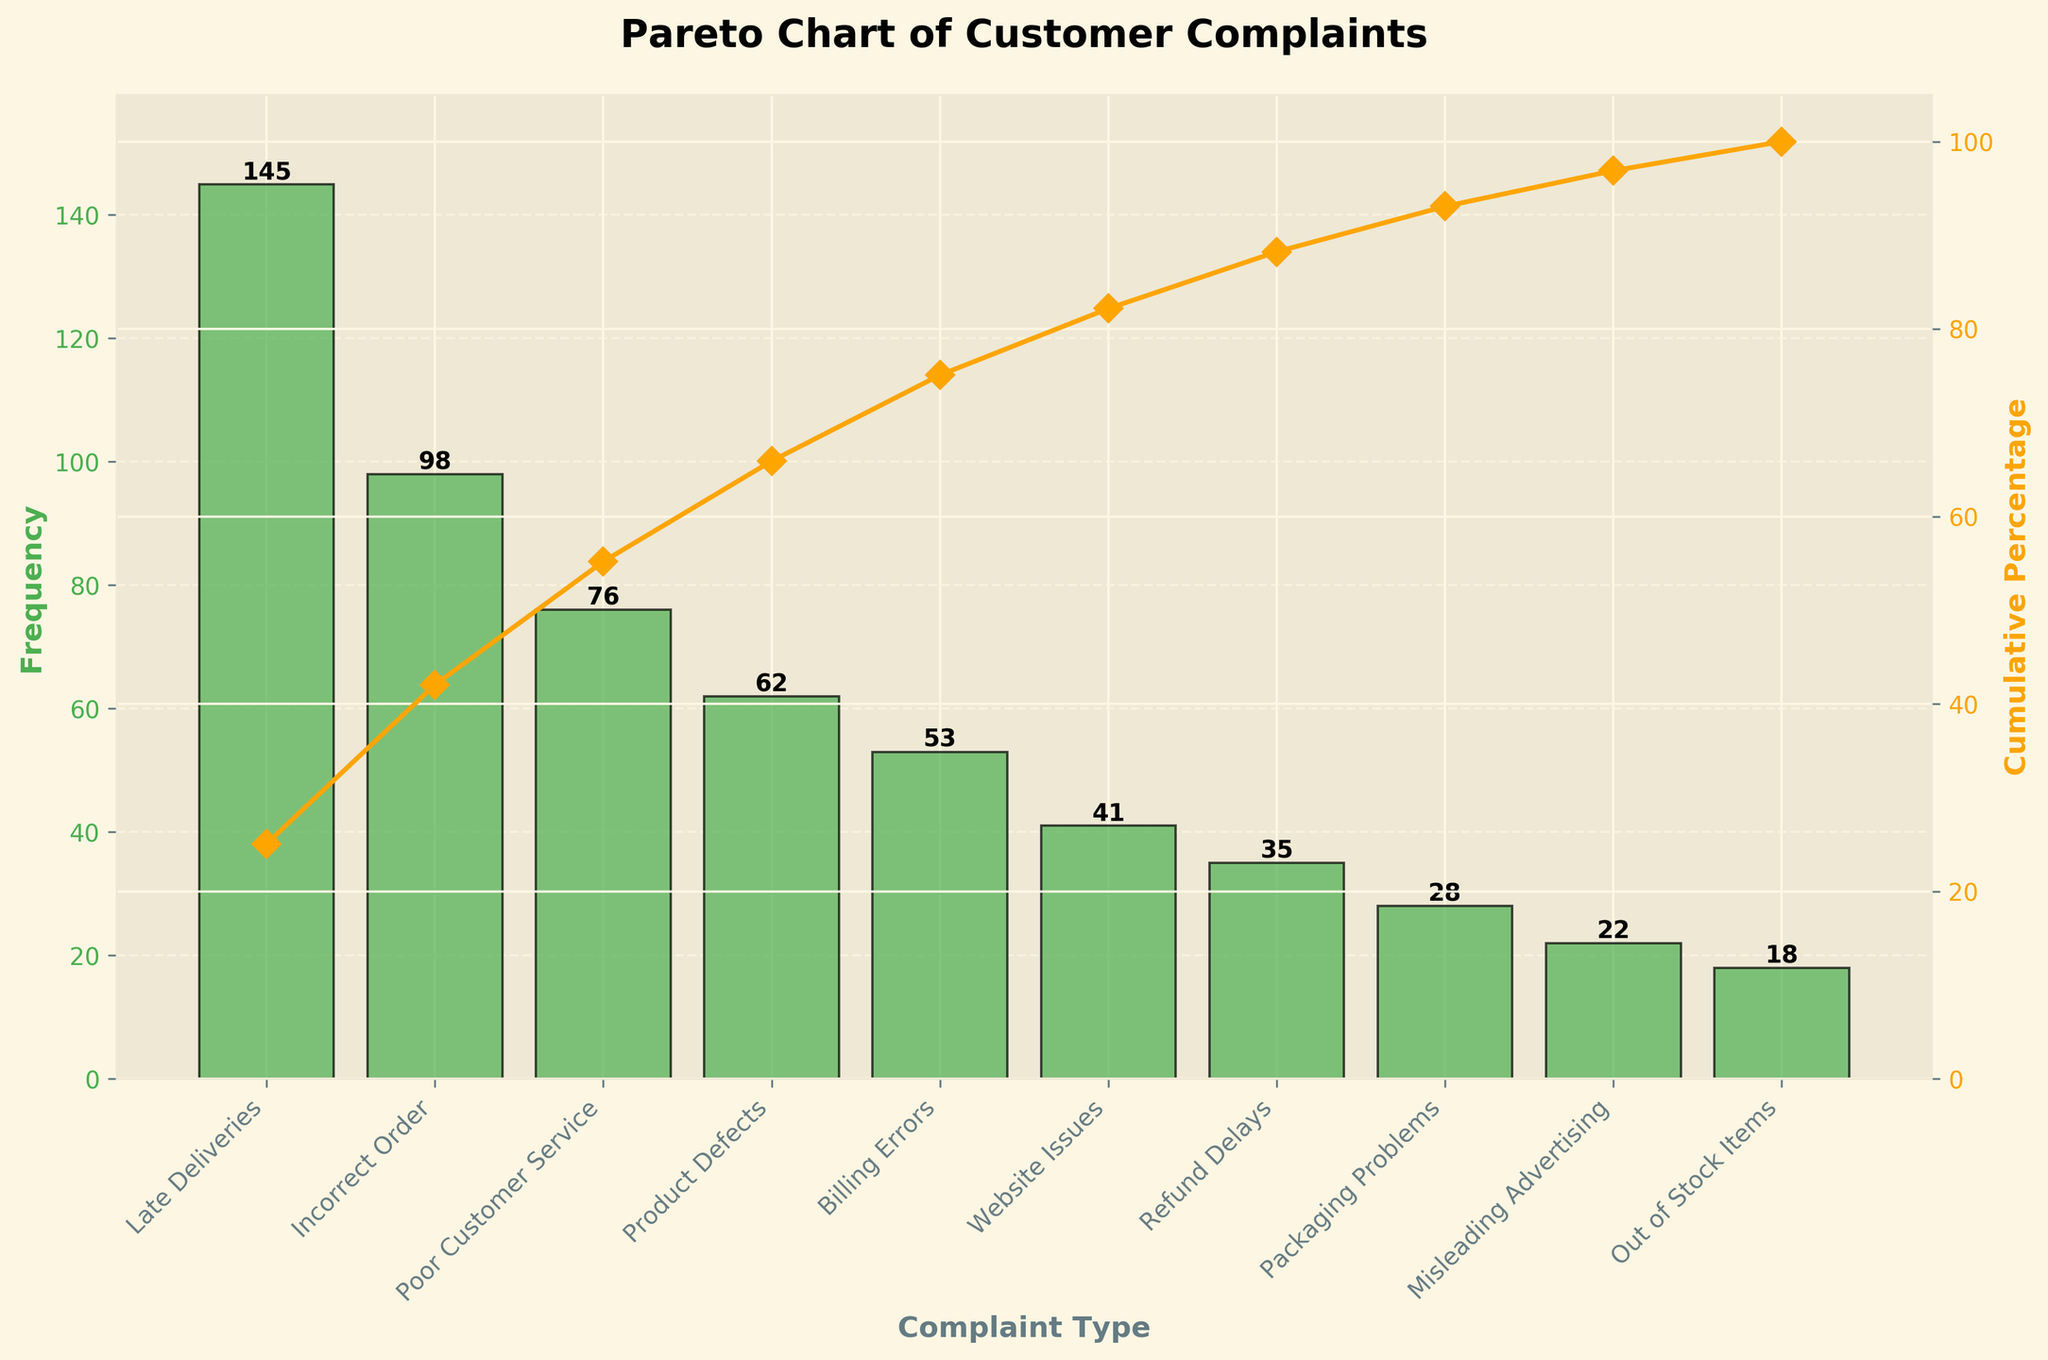What's the title of the chart? The title is located at the top center of the chart. It reads "Pareto Chart of Customer Complaints".
Answer: Pareto Chart of Customer Complaints Which complaint type has the highest frequency? Look at the tallest bar in the bar chart, which represents the complaint type with the highest frequency.
Answer: Late Deliveries What is the cumulative percentage of the top three most frequent complaint types? The cumulative percentage is plotted with a line and marker. To find it, look at the percentage on the y-axis corresponding to the third data point from the left.
Answer: 72.72% How many types of complaints have a frequency less than 50? Identify all the bars with heights less than 50 on the y-axis and count the corresponding x-axis labels.
Answer: Five What is the frequency range of the complaints shown? The frequency range is the difference between the highest and lowest frequencies. The highest frequency is for Late Deliveries (145), and the lowest is for Out of Stock Items (18). Subtract these values.
Answer: 127 Which complaint type contributes around the 80% cumulative percentage mark? Find the point on the cumulative percentage line that is closest to 80% and trace it to the corresponding complaint type on the x-axis.
Answer: Product Defects Compare the combined frequency of Incorrect Order and Poor Customer Service with the frequency of Late Deliveries. Which is higher? Sum the frequencies of Incorrect Order (98) and Poor Customer Service (76). Compare it with the frequency of Late Deliveries (145).
Answer: Combined frequency: 174, which is higher than 145 How many complaint types contribute to 50% of the total complaints? Trace the cumulative percentage line to the 50% mark and count the number of complaint types contributing to this point.
Answer: Three What is the percentage difference in cumulative percentage between Product Defects and Billing Errors? Find the cumulative percentages for Product Defects and Billing Errors, subtract the smaller percentage from the larger.
Answer: 56.04% - 40.83% = 15.21% Which two complaint types have the smallest combined frequency, and what are their frequencies? Identify the two smallest bars on the chart, which are for Misleading Advertising and Out of Stock Items. Check their heights (22 and 18).
Answer: 22 and 18 